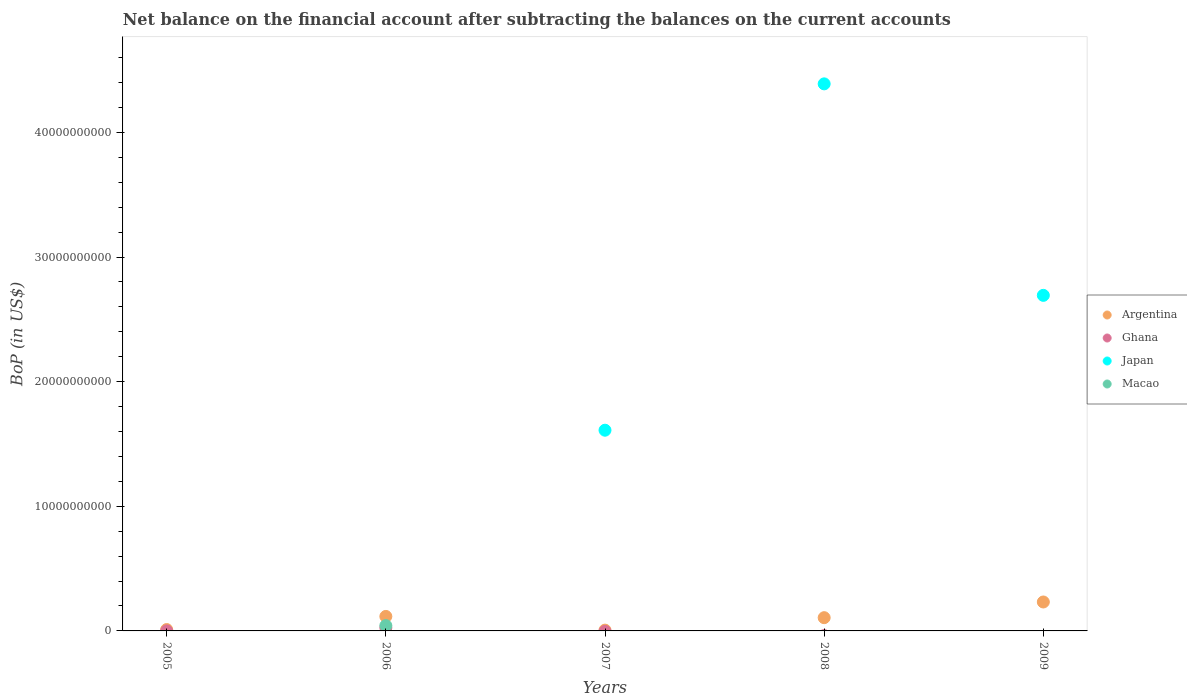Is the number of dotlines equal to the number of legend labels?
Give a very brief answer. No. What is the Balance of Payments in Argentina in 2006?
Provide a succinct answer. 1.16e+09. Across all years, what is the maximum Balance of Payments in Japan?
Ensure brevity in your answer.  4.39e+1. What is the total Balance of Payments in Argentina in the graph?
Your answer should be compact. 4.72e+09. What is the difference between the Balance of Payments in Argentina in 2006 and that in 2007?
Provide a succinct answer. 1.10e+09. What is the difference between the Balance of Payments in Japan in 2009 and the Balance of Payments in Argentina in 2008?
Provide a short and direct response. 2.59e+1. What is the average Balance of Payments in Argentina per year?
Provide a short and direct response. 9.44e+08. In the year 2009, what is the difference between the Balance of Payments in Argentina and Balance of Payments in Japan?
Offer a very short reply. -2.46e+1. In how many years, is the Balance of Payments in Japan greater than 36000000000 US$?
Your answer should be compact. 1. What is the ratio of the Balance of Payments in Japan in 2008 to that in 2009?
Your answer should be very brief. 1.63. Is the difference between the Balance of Payments in Argentina in 2007 and 2009 greater than the difference between the Balance of Payments in Japan in 2007 and 2009?
Give a very brief answer. Yes. What is the difference between the highest and the second highest Balance of Payments in Argentina?
Ensure brevity in your answer.  1.16e+09. What is the difference between the highest and the lowest Balance of Payments in Macao?
Your answer should be very brief. 4.27e+08. Is it the case that in every year, the sum of the Balance of Payments in Macao and Balance of Payments in Ghana  is greater than the Balance of Payments in Argentina?
Keep it short and to the point. No. Is the Balance of Payments in Japan strictly greater than the Balance of Payments in Macao over the years?
Your answer should be compact. No. Is the Balance of Payments in Argentina strictly less than the Balance of Payments in Ghana over the years?
Make the answer very short. No. How many dotlines are there?
Your answer should be compact. 4. What is the difference between two consecutive major ticks on the Y-axis?
Make the answer very short. 1.00e+1. Are the values on the major ticks of Y-axis written in scientific E-notation?
Make the answer very short. No. Does the graph contain grids?
Offer a very short reply. No. Where does the legend appear in the graph?
Ensure brevity in your answer.  Center right. How are the legend labels stacked?
Your answer should be compact. Vertical. What is the title of the graph?
Offer a terse response. Net balance on the financial account after subtracting the balances on the current accounts. What is the label or title of the X-axis?
Keep it short and to the point. Years. What is the label or title of the Y-axis?
Give a very brief answer. BoP (in US$). What is the BoP (in US$) in Argentina in 2005?
Your answer should be compact. 1.10e+08. What is the BoP (in US$) in Ghana in 2005?
Offer a very short reply. 3.57e+06. What is the BoP (in US$) in Japan in 2005?
Give a very brief answer. 0. What is the BoP (in US$) of Argentina in 2006?
Your answer should be very brief. 1.16e+09. What is the BoP (in US$) in Ghana in 2006?
Offer a terse response. 2.51e+08. What is the BoP (in US$) of Japan in 2006?
Give a very brief answer. 0. What is the BoP (in US$) of Macao in 2006?
Give a very brief answer. 4.27e+08. What is the BoP (in US$) in Argentina in 2007?
Offer a terse response. 6.32e+07. What is the BoP (in US$) of Japan in 2007?
Provide a succinct answer. 1.61e+1. What is the BoP (in US$) in Argentina in 2008?
Your response must be concise. 1.06e+09. What is the BoP (in US$) of Japan in 2008?
Your response must be concise. 4.39e+1. What is the BoP (in US$) in Macao in 2008?
Keep it short and to the point. 0. What is the BoP (in US$) of Argentina in 2009?
Provide a short and direct response. 2.32e+09. What is the BoP (in US$) of Ghana in 2009?
Provide a succinct answer. 0. What is the BoP (in US$) in Japan in 2009?
Your response must be concise. 2.69e+1. What is the BoP (in US$) of Macao in 2009?
Ensure brevity in your answer.  0. Across all years, what is the maximum BoP (in US$) of Argentina?
Ensure brevity in your answer.  2.32e+09. Across all years, what is the maximum BoP (in US$) of Ghana?
Provide a succinct answer. 2.51e+08. Across all years, what is the maximum BoP (in US$) of Japan?
Offer a terse response. 4.39e+1. Across all years, what is the maximum BoP (in US$) of Macao?
Provide a short and direct response. 4.27e+08. Across all years, what is the minimum BoP (in US$) in Argentina?
Keep it short and to the point. 6.32e+07. Across all years, what is the minimum BoP (in US$) in Japan?
Provide a short and direct response. 0. What is the total BoP (in US$) of Argentina in the graph?
Your response must be concise. 4.72e+09. What is the total BoP (in US$) of Ghana in the graph?
Keep it short and to the point. 2.54e+08. What is the total BoP (in US$) of Japan in the graph?
Your answer should be compact. 8.69e+1. What is the total BoP (in US$) in Macao in the graph?
Offer a very short reply. 4.27e+08. What is the difference between the BoP (in US$) of Argentina in 2005 and that in 2006?
Make the answer very short. -1.05e+09. What is the difference between the BoP (in US$) of Ghana in 2005 and that in 2006?
Provide a short and direct response. -2.47e+08. What is the difference between the BoP (in US$) in Argentina in 2005 and that in 2007?
Make the answer very short. 4.69e+07. What is the difference between the BoP (in US$) in Argentina in 2005 and that in 2008?
Give a very brief answer. -9.53e+08. What is the difference between the BoP (in US$) in Argentina in 2005 and that in 2009?
Offer a very short reply. -2.21e+09. What is the difference between the BoP (in US$) in Argentina in 2006 and that in 2007?
Provide a succinct answer. 1.10e+09. What is the difference between the BoP (in US$) of Argentina in 2006 and that in 2008?
Offer a terse response. 1.00e+08. What is the difference between the BoP (in US$) in Argentina in 2006 and that in 2009?
Offer a very short reply. -1.16e+09. What is the difference between the BoP (in US$) in Argentina in 2007 and that in 2008?
Provide a short and direct response. -9.99e+08. What is the difference between the BoP (in US$) in Japan in 2007 and that in 2008?
Give a very brief answer. -2.78e+1. What is the difference between the BoP (in US$) in Argentina in 2007 and that in 2009?
Offer a terse response. -2.26e+09. What is the difference between the BoP (in US$) in Japan in 2007 and that in 2009?
Your answer should be compact. -1.08e+1. What is the difference between the BoP (in US$) in Argentina in 2008 and that in 2009?
Keep it short and to the point. -1.26e+09. What is the difference between the BoP (in US$) in Japan in 2008 and that in 2009?
Give a very brief answer. 1.70e+1. What is the difference between the BoP (in US$) of Argentina in 2005 and the BoP (in US$) of Ghana in 2006?
Your answer should be compact. -1.41e+08. What is the difference between the BoP (in US$) of Argentina in 2005 and the BoP (in US$) of Macao in 2006?
Your response must be concise. -3.17e+08. What is the difference between the BoP (in US$) in Ghana in 2005 and the BoP (in US$) in Macao in 2006?
Give a very brief answer. -4.23e+08. What is the difference between the BoP (in US$) in Argentina in 2005 and the BoP (in US$) in Japan in 2007?
Provide a succinct answer. -1.60e+1. What is the difference between the BoP (in US$) in Ghana in 2005 and the BoP (in US$) in Japan in 2007?
Your answer should be very brief. -1.61e+1. What is the difference between the BoP (in US$) in Argentina in 2005 and the BoP (in US$) in Japan in 2008?
Make the answer very short. -4.38e+1. What is the difference between the BoP (in US$) in Ghana in 2005 and the BoP (in US$) in Japan in 2008?
Provide a short and direct response. -4.39e+1. What is the difference between the BoP (in US$) of Argentina in 2005 and the BoP (in US$) of Japan in 2009?
Give a very brief answer. -2.68e+1. What is the difference between the BoP (in US$) in Ghana in 2005 and the BoP (in US$) in Japan in 2009?
Your response must be concise. -2.69e+1. What is the difference between the BoP (in US$) in Argentina in 2006 and the BoP (in US$) in Japan in 2007?
Offer a terse response. -1.49e+1. What is the difference between the BoP (in US$) in Ghana in 2006 and the BoP (in US$) in Japan in 2007?
Keep it short and to the point. -1.59e+1. What is the difference between the BoP (in US$) in Argentina in 2006 and the BoP (in US$) in Japan in 2008?
Offer a very short reply. -4.27e+1. What is the difference between the BoP (in US$) of Ghana in 2006 and the BoP (in US$) of Japan in 2008?
Offer a very short reply. -4.36e+1. What is the difference between the BoP (in US$) of Argentina in 2006 and the BoP (in US$) of Japan in 2009?
Provide a succinct answer. -2.58e+1. What is the difference between the BoP (in US$) of Ghana in 2006 and the BoP (in US$) of Japan in 2009?
Make the answer very short. -2.67e+1. What is the difference between the BoP (in US$) in Argentina in 2007 and the BoP (in US$) in Japan in 2008?
Offer a terse response. -4.38e+1. What is the difference between the BoP (in US$) in Argentina in 2007 and the BoP (in US$) in Japan in 2009?
Make the answer very short. -2.69e+1. What is the difference between the BoP (in US$) in Argentina in 2008 and the BoP (in US$) in Japan in 2009?
Your answer should be compact. -2.59e+1. What is the average BoP (in US$) in Argentina per year?
Ensure brevity in your answer.  9.44e+08. What is the average BoP (in US$) in Ghana per year?
Offer a terse response. 5.09e+07. What is the average BoP (in US$) of Japan per year?
Offer a terse response. 1.74e+1. What is the average BoP (in US$) in Macao per year?
Offer a terse response. 8.53e+07. In the year 2005, what is the difference between the BoP (in US$) in Argentina and BoP (in US$) in Ghana?
Offer a terse response. 1.07e+08. In the year 2006, what is the difference between the BoP (in US$) of Argentina and BoP (in US$) of Ghana?
Give a very brief answer. 9.12e+08. In the year 2006, what is the difference between the BoP (in US$) in Argentina and BoP (in US$) in Macao?
Offer a terse response. 7.36e+08. In the year 2006, what is the difference between the BoP (in US$) of Ghana and BoP (in US$) of Macao?
Provide a succinct answer. -1.76e+08. In the year 2007, what is the difference between the BoP (in US$) in Argentina and BoP (in US$) in Japan?
Ensure brevity in your answer.  -1.60e+1. In the year 2008, what is the difference between the BoP (in US$) of Argentina and BoP (in US$) of Japan?
Give a very brief answer. -4.28e+1. In the year 2009, what is the difference between the BoP (in US$) of Argentina and BoP (in US$) of Japan?
Provide a succinct answer. -2.46e+1. What is the ratio of the BoP (in US$) of Argentina in 2005 to that in 2006?
Provide a succinct answer. 0.09. What is the ratio of the BoP (in US$) of Ghana in 2005 to that in 2006?
Offer a very short reply. 0.01. What is the ratio of the BoP (in US$) of Argentina in 2005 to that in 2007?
Give a very brief answer. 1.74. What is the ratio of the BoP (in US$) of Argentina in 2005 to that in 2008?
Provide a short and direct response. 0.1. What is the ratio of the BoP (in US$) in Argentina in 2005 to that in 2009?
Provide a short and direct response. 0.05. What is the ratio of the BoP (in US$) in Argentina in 2006 to that in 2007?
Your response must be concise. 18.4. What is the ratio of the BoP (in US$) in Argentina in 2006 to that in 2008?
Your answer should be compact. 1.09. What is the ratio of the BoP (in US$) of Argentina in 2006 to that in 2009?
Keep it short and to the point. 0.5. What is the ratio of the BoP (in US$) in Argentina in 2007 to that in 2008?
Make the answer very short. 0.06. What is the ratio of the BoP (in US$) of Japan in 2007 to that in 2008?
Give a very brief answer. 0.37. What is the ratio of the BoP (in US$) in Argentina in 2007 to that in 2009?
Offer a terse response. 0.03. What is the ratio of the BoP (in US$) of Japan in 2007 to that in 2009?
Keep it short and to the point. 0.6. What is the ratio of the BoP (in US$) of Argentina in 2008 to that in 2009?
Give a very brief answer. 0.46. What is the ratio of the BoP (in US$) in Japan in 2008 to that in 2009?
Offer a terse response. 1.63. What is the difference between the highest and the second highest BoP (in US$) of Argentina?
Your answer should be very brief. 1.16e+09. What is the difference between the highest and the second highest BoP (in US$) in Japan?
Your answer should be compact. 1.70e+1. What is the difference between the highest and the lowest BoP (in US$) in Argentina?
Make the answer very short. 2.26e+09. What is the difference between the highest and the lowest BoP (in US$) in Ghana?
Make the answer very short. 2.51e+08. What is the difference between the highest and the lowest BoP (in US$) of Japan?
Provide a succinct answer. 4.39e+1. What is the difference between the highest and the lowest BoP (in US$) in Macao?
Provide a short and direct response. 4.27e+08. 